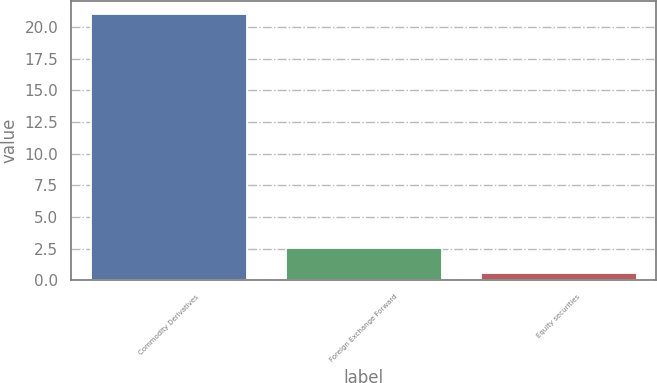Convert chart to OTSL. <chart><loc_0><loc_0><loc_500><loc_500><bar_chart><fcel>Commodity Derivatives<fcel>Foreign Exchange Forward<fcel>Equity securities<nl><fcel>21<fcel>2.59<fcel>0.55<nl></chart> 